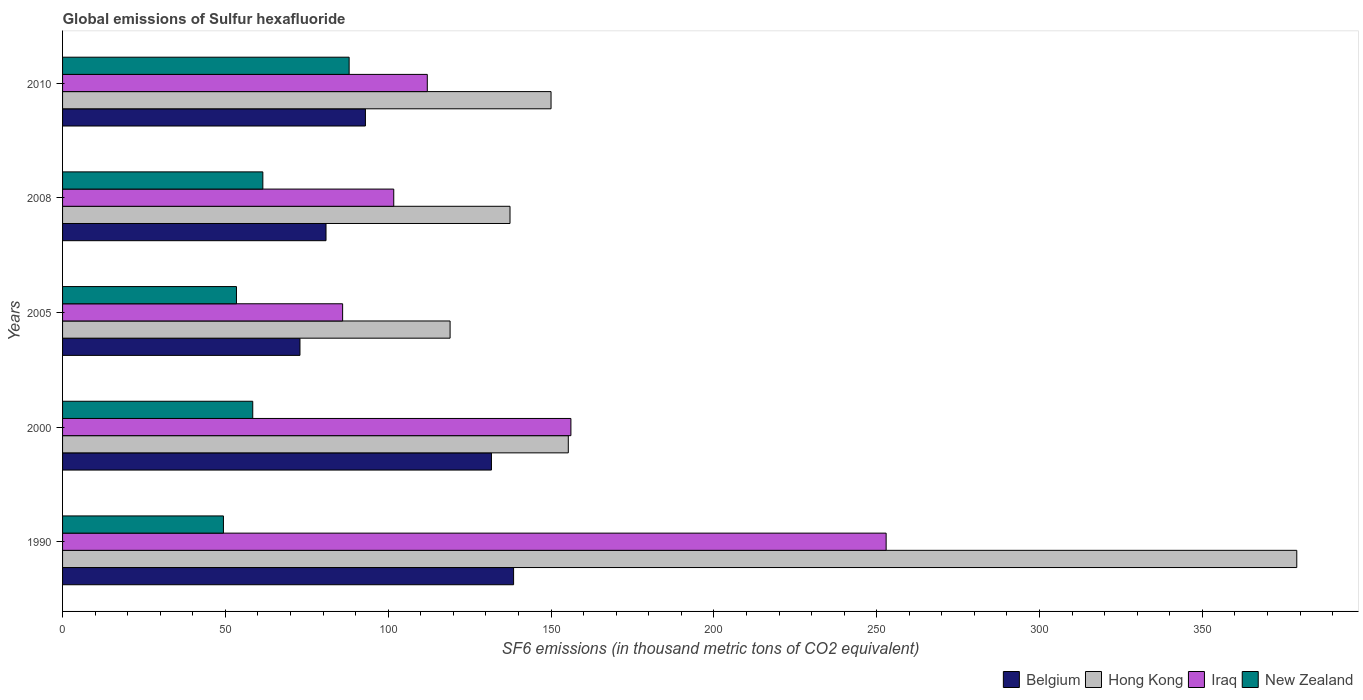How many different coloured bars are there?
Provide a succinct answer. 4. Are the number of bars per tick equal to the number of legend labels?
Your answer should be compact. Yes. In how many cases, is the number of bars for a given year not equal to the number of legend labels?
Keep it short and to the point. 0. What is the global emissions of Sulfur hexafluoride in Belgium in 2008?
Your response must be concise. 80.9. Across all years, what is the maximum global emissions of Sulfur hexafluoride in Hong Kong?
Your answer should be very brief. 379. In which year was the global emissions of Sulfur hexafluoride in Hong Kong minimum?
Your answer should be compact. 2005. What is the total global emissions of Sulfur hexafluoride in Hong Kong in the graph?
Your answer should be very brief. 940.7. What is the difference between the global emissions of Sulfur hexafluoride in Iraq in 1990 and that in 2010?
Offer a terse response. 140.9. What is the difference between the global emissions of Sulfur hexafluoride in Belgium in 2010 and the global emissions of Sulfur hexafluoride in Iraq in 2000?
Offer a terse response. -63.1. What is the average global emissions of Sulfur hexafluoride in Iraq per year?
Give a very brief answer. 141.74. In the year 1990, what is the difference between the global emissions of Sulfur hexafluoride in New Zealand and global emissions of Sulfur hexafluoride in Belgium?
Provide a succinct answer. -89.1. What is the ratio of the global emissions of Sulfur hexafluoride in New Zealand in 2008 to that in 2010?
Provide a succinct answer. 0.7. Is the global emissions of Sulfur hexafluoride in Iraq in 1990 less than that in 2000?
Your answer should be compact. No. What is the difference between the highest and the lowest global emissions of Sulfur hexafluoride in Iraq?
Your answer should be very brief. 166.9. What does the 2nd bar from the bottom in 2005 represents?
Make the answer very short. Hong Kong. Are all the bars in the graph horizontal?
Provide a succinct answer. Yes. How many years are there in the graph?
Provide a short and direct response. 5. Where does the legend appear in the graph?
Offer a terse response. Bottom right. How many legend labels are there?
Offer a terse response. 4. What is the title of the graph?
Give a very brief answer. Global emissions of Sulfur hexafluoride. What is the label or title of the X-axis?
Make the answer very short. SF6 emissions (in thousand metric tons of CO2 equivalent). What is the SF6 emissions (in thousand metric tons of CO2 equivalent) in Belgium in 1990?
Provide a short and direct response. 138.5. What is the SF6 emissions (in thousand metric tons of CO2 equivalent) of Hong Kong in 1990?
Ensure brevity in your answer.  379. What is the SF6 emissions (in thousand metric tons of CO2 equivalent) in Iraq in 1990?
Offer a terse response. 252.9. What is the SF6 emissions (in thousand metric tons of CO2 equivalent) in New Zealand in 1990?
Offer a terse response. 49.4. What is the SF6 emissions (in thousand metric tons of CO2 equivalent) in Belgium in 2000?
Provide a succinct answer. 131.7. What is the SF6 emissions (in thousand metric tons of CO2 equivalent) of Hong Kong in 2000?
Your response must be concise. 155.3. What is the SF6 emissions (in thousand metric tons of CO2 equivalent) of Iraq in 2000?
Keep it short and to the point. 156.1. What is the SF6 emissions (in thousand metric tons of CO2 equivalent) of New Zealand in 2000?
Your response must be concise. 58.4. What is the SF6 emissions (in thousand metric tons of CO2 equivalent) in Belgium in 2005?
Your response must be concise. 72.9. What is the SF6 emissions (in thousand metric tons of CO2 equivalent) of Hong Kong in 2005?
Your answer should be compact. 119. What is the SF6 emissions (in thousand metric tons of CO2 equivalent) in New Zealand in 2005?
Provide a short and direct response. 53.4. What is the SF6 emissions (in thousand metric tons of CO2 equivalent) of Belgium in 2008?
Make the answer very short. 80.9. What is the SF6 emissions (in thousand metric tons of CO2 equivalent) in Hong Kong in 2008?
Ensure brevity in your answer.  137.4. What is the SF6 emissions (in thousand metric tons of CO2 equivalent) in Iraq in 2008?
Your answer should be very brief. 101.7. What is the SF6 emissions (in thousand metric tons of CO2 equivalent) in New Zealand in 2008?
Provide a short and direct response. 61.5. What is the SF6 emissions (in thousand metric tons of CO2 equivalent) in Belgium in 2010?
Ensure brevity in your answer.  93. What is the SF6 emissions (in thousand metric tons of CO2 equivalent) of Hong Kong in 2010?
Give a very brief answer. 150. What is the SF6 emissions (in thousand metric tons of CO2 equivalent) in Iraq in 2010?
Your answer should be very brief. 112. What is the SF6 emissions (in thousand metric tons of CO2 equivalent) in New Zealand in 2010?
Ensure brevity in your answer.  88. Across all years, what is the maximum SF6 emissions (in thousand metric tons of CO2 equivalent) of Belgium?
Your answer should be compact. 138.5. Across all years, what is the maximum SF6 emissions (in thousand metric tons of CO2 equivalent) in Hong Kong?
Your response must be concise. 379. Across all years, what is the maximum SF6 emissions (in thousand metric tons of CO2 equivalent) in Iraq?
Your response must be concise. 252.9. Across all years, what is the minimum SF6 emissions (in thousand metric tons of CO2 equivalent) of Belgium?
Make the answer very short. 72.9. Across all years, what is the minimum SF6 emissions (in thousand metric tons of CO2 equivalent) of Hong Kong?
Offer a terse response. 119. Across all years, what is the minimum SF6 emissions (in thousand metric tons of CO2 equivalent) in Iraq?
Offer a very short reply. 86. Across all years, what is the minimum SF6 emissions (in thousand metric tons of CO2 equivalent) in New Zealand?
Offer a very short reply. 49.4. What is the total SF6 emissions (in thousand metric tons of CO2 equivalent) of Belgium in the graph?
Provide a short and direct response. 517. What is the total SF6 emissions (in thousand metric tons of CO2 equivalent) of Hong Kong in the graph?
Provide a short and direct response. 940.7. What is the total SF6 emissions (in thousand metric tons of CO2 equivalent) in Iraq in the graph?
Give a very brief answer. 708.7. What is the total SF6 emissions (in thousand metric tons of CO2 equivalent) of New Zealand in the graph?
Ensure brevity in your answer.  310.7. What is the difference between the SF6 emissions (in thousand metric tons of CO2 equivalent) in Belgium in 1990 and that in 2000?
Make the answer very short. 6.8. What is the difference between the SF6 emissions (in thousand metric tons of CO2 equivalent) in Hong Kong in 1990 and that in 2000?
Make the answer very short. 223.7. What is the difference between the SF6 emissions (in thousand metric tons of CO2 equivalent) of Iraq in 1990 and that in 2000?
Your answer should be very brief. 96.8. What is the difference between the SF6 emissions (in thousand metric tons of CO2 equivalent) of Belgium in 1990 and that in 2005?
Give a very brief answer. 65.6. What is the difference between the SF6 emissions (in thousand metric tons of CO2 equivalent) in Hong Kong in 1990 and that in 2005?
Provide a succinct answer. 260. What is the difference between the SF6 emissions (in thousand metric tons of CO2 equivalent) in Iraq in 1990 and that in 2005?
Offer a terse response. 166.9. What is the difference between the SF6 emissions (in thousand metric tons of CO2 equivalent) of Belgium in 1990 and that in 2008?
Give a very brief answer. 57.6. What is the difference between the SF6 emissions (in thousand metric tons of CO2 equivalent) of Hong Kong in 1990 and that in 2008?
Offer a very short reply. 241.6. What is the difference between the SF6 emissions (in thousand metric tons of CO2 equivalent) in Iraq in 1990 and that in 2008?
Give a very brief answer. 151.2. What is the difference between the SF6 emissions (in thousand metric tons of CO2 equivalent) in New Zealand in 1990 and that in 2008?
Make the answer very short. -12.1. What is the difference between the SF6 emissions (in thousand metric tons of CO2 equivalent) of Belgium in 1990 and that in 2010?
Offer a terse response. 45.5. What is the difference between the SF6 emissions (in thousand metric tons of CO2 equivalent) of Hong Kong in 1990 and that in 2010?
Give a very brief answer. 229. What is the difference between the SF6 emissions (in thousand metric tons of CO2 equivalent) in Iraq in 1990 and that in 2010?
Your answer should be very brief. 140.9. What is the difference between the SF6 emissions (in thousand metric tons of CO2 equivalent) of New Zealand in 1990 and that in 2010?
Provide a short and direct response. -38.6. What is the difference between the SF6 emissions (in thousand metric tons of CO2 equivalent) of Belgium in 2000 and that in 2005?
Provide a succinct answer. 58.8. What is the difference between the SF6 emissions (in thousand metric tons of CO2 equivalent) of Hong Kong in 2000 and that in 2005?
Your answer should be compact. 36.3. What is the difference between the SF6 emissions (in thousand metric tons of CO2 equivalent) of Iraq in 2000 and that in 2005?
Your response must be concise. 70.1. What is the difference between the SF6 emissions (in thousand metric tons of CO2 equivalent) in Belgium in 2000 and that in 2008?
Make the answer very short. 50.8. What is the difference between the SF6 emissions (in thousand metric tons of CO2 equivalent) in Iraq in 2000 and that in 2008?
Offer a very short reply. 54.4. What is the difference between the SF6 emissions (in thousand metric tons of CO2 equivalent) in New Zealand in 2000 and that in 2008?
Provide a short and direct response. -3.1. What is the difference between the SF6 emissions (in thousand metric tons of CO2 equivalent) of Belgium in 2000 and that in 2010?
Give a very brief answer. 38.7. What is the difference between the SF6 emissions (in thousand metric tons of CO2 equivalent) of Hong Kong in 2000 and that in 2010?
Ensure brevity in your answer.  5.3. What is the difference between the SF6 emissions (in thousand metric tons of CO2 equivalent) in Iraq in 2000 and that in 2010?
Make the answer very short. 44.1. What is the difference between the SF6 emissions (in thousand metric tons of CO2 equivalent) of New Zealand in 2000 and that in 2010?
Your response must be concise. -29.6. What is the difference between the SF6 emissions (in thousand metric tons of CO2 equivalent) of Belgium in 2005 and that in 2008?
Keep it short and to the point. -8. What is the difference between the SF6 emissions (in thousand metric tons of CO2 equivalent) in Hong Kong in 2005 and that in 2008?
Provide a succinct answer. -18.4. What is the difference between the SF6 emissions (in thousand metric tons of CO2 equivalent) of Iraq in 2005 and that in 2008?
Provide a succinct answer. -15.7. What is the difference between the SF6 emissions (in thousand metric tons of CO2 equivalent) in Belgium in 2005 and that in 2010?
Provide a succinct answer. -20.1. What is the difference between the SF6 emissions (in thousand metric tons of CO2 equivalent) in Hong Kong in 2005 and that in 2010?
Provide a short and direct response. -31. What is the difference between the SF6 emissions (in thousand metric tons of CO2 equivalent) in Iraq in 2005 and that in 2010?
Provide a short and direct response. -26. What is the difference between the SF6 emissions (in thousand metric tons of CO2 equivalent) of New Zealand in 2005 and that in 2010?
Your answer should be very brief. -34.6. What is the difference between the SF6 emissions (in thousand metric tons of CO2 equivalent) in Belgium in 2008 and that in 2010?
Your answer should be compact. -12.1. What is the difference between the SF6 emissions (in thousand metric tons of CO2 equivalent) of Iraq in 2008 and that in 2010?
Provide a succinct answer. -10.3. What is the difference between the SF6 emissions (in thousand metric tons of CO2 equivalent) in New Zealand in 2008 and that in 2010?
Your response must be concise. -26.5. What is the difference between the SF6 emissions (in thousand metric tons of CO2 equivalent) of Belgium in 1990 and the SF6 emissions (in thousand metric tons of CO2 equivalent) of Hong Kong in 2000?
Keep it short and to the point. -16.8. What is the difference between the SF6 emissions (in thousand metric tons of CO2 equivalent) in Belgium in 1990 and the SF6 emissions (in thousand metric tons of CO2 equivalent) in Iraq in 2000?
Provide a succinct answer. -17.6. What is the difference between the SF6 emissions (in thousand metric tons of CO2 equivalent) of Belgium in 1990 and the SF6 emissions (in thousand metric tons of CO2 equivalent) of New Zealand in 2000?
Keep it short and to the point. 80.1. What is the difference between the SF6 emissions (in thousand metric tons of CO2 equivalent) in Hong Kong in 1990 and the SF6 emissions (in thousand metric tons of CO2 equivalent) in Iraq in 2000?
Keep it short and to the point. 222.9. What is the difference between the SF6 emissions (in thousand metric tons of CO2 equivalent) in Hong Kong in 1990 and the SF6 emissions (in thousand metric tons of CO2 equivalent) in New Zealand in 2000?
Offer a terse response. 320.6. What is the difference between the SF6 emissions (in thousand metric tons of CO2 equivalent) of Iraq in 1990 and the SF6 emissions (in thousand metric tons of CO2 equivalent) of New Zealand in 2000?
Your answer should be compact. 194.5. What is the difference between the SF6 emissions (in thousand metric tons of CO2 equivalent) in Belgium in 1990 and the SF6 emissions (in thousand metric tons of CO2 equivalent) in Hong Kong in 2005?
Offer a very short reply. 19.5. What is the difference between the SF6 emissions (in thousand metric tons of CO2 equivalent) of Belgium in 1990 and the SF6 emissions (in thousand metric tons of CO2 equivalent) of Iraq in 2005?
Give a very brief answer. 52.5. What is the difference between the SF6 emissions (in thousand metric tons of CO2 equivalent) in Belgium in 1990 and the SF6 emissions (in thousand metric tons of CO2 equivalent) in New Zealand in 2005?
Keep it short and to the point. 85.1. What is the difference between the SF6 emissions (in thousand metric tons of CO2 equivalent) of Hong Kong in 1990 and the SF6 emissions (in thousand metric tons of CO2 equivalent) of Iraq in 2005?
Provide a short and direct response. 293. What is the difference between the SF6 emissions (in thousand metric tons of CO2 equivalent) of Hong Kong in 1990 and the SF6 emissions (in thousand metric tons of CO2 equivalent) of New Zealand in 2005?
Ensure brevity in your answer.  325.6. What is the difference between the SF6 emissions (in thousand metric tons of CO2 equivalent) of Iraq in 1990 and the SF6 emissions (in thousand metric tons of CO2 equivalent) of New Zealand in 2005?
Your answer should be compact. 199.5. What is the difference between the SF6 emissions (in thousand metric tons of CO2 equivalent) in Belgium in 1990 and the SF6 emissions (in thousand metric tons of CO2 equivalent) in Hong Kong in 2008?
Your response must be concise. 1.1. What is the difference between the SF6 emissions (in thousand metric tons of CO2 equivalent) in Belgium in 1990 and the SF6 emissions (in thousand metric tons of CO2 equivalent) in Iraq in 2008?
Give a very brief answer. 36.8. What is the difference between the SF6 emissions (in thousand metric tons of CO2 equivalent) of Hong Kong in 1990 and the SF6 emissions (in thousand metric tons of CO2 equivalent) of Iraq in 2008?
Provide a succinct answer. 277.3. What is the difference between the SF6 emissions (in thousand metric tons of CO2 equivalent) in Hong Kong in 1990 and the SF6 emissions (in thousand metric tons of CO2 equivalent) in New Zealand in 2008?
Your response must be concise. 317.5. What is the difference between the SF6 emissions (in thousand metric tons of CO2 equivalent) of Iraq in 1990 and the SF6 emissions (in thousand metric tons of CO2 equivalent) of New Zealand in 2008?
Offer a very short reply. 191.4. What is the difference between the SF6 emissions (in thousand metric tons of CO2 equivalent) of Belgium in 1990 and the SF6 emissions (in thousand metric tons of CO2 equivalent) of Iraq in 2010?
Your answer should be compact. 26.5. What is the difference between the SF6 emissions (in thousand metric tons of CO2 equivalent) of Belgium in 1990 and the SF6 emissions (in thousand metric tons of CO2 equivalent) of New Zealand in 2010?
Provide a short and direct response. 50.5. What is the difference between the SF6 emissions (in thousand metric tons of CO2 equivalent) of Hong Kong in 1990 and the SF6 emissions (in thousand metric tons of CO2 equivalent) of Iraq in 2010?
Your answer should be compact. 267. What is the difference between the SF6 emissions (in thousand metric tons of CO2 equivalent) of Hong Kong in 1990 and the SF6 emissions (in thousand metric tons of CO2 equivalent) of New Zealand in 2010?
Give a very brief answer. 291. What is the difference between the SF6 emissions (in thousand metric tons of CO2 equivalent) of Iraq in 1990 and the SF6 emissions (in thousand metric tons of CO2 equivalent) of New Zealand in 2010?
Offer a very short reply. 164.9. What is the difference between the SF6 emissions (in thousand metric tons of CO2 equivalent) of Belgium in 2000 and the SF6 emissions (in thousand metric tons of CO2 equivalent) of Hong Kong in 2005?
Provide a succinct answer. 12.7. What is the difference between the SF6 emissions (in thousand metric tons of CO2 equivalent) in Belgium in 2000 and the SF6 emissions (in thousand metric tons of CO2 equivalent) in Iraq in 2005?
Your answer should be compact. 45.7. What is the difference between the SF6 emissions (in thousand metric tons of CO2 equivalent) of Belgium in 2000 and the SF6 emissions (in thousand metric tons of CO2 equivalent) of New Zealand in 2005?
Your response must be concise. 78.3. What is the difference between the SF6 emissions (in thousand metric tons of CO2 equivalent) in Hong Kong in 2000 and the SF6 emissions (in thousand metric tons of CO2 equivalent) in Iraq in 2005?
Give a very brief answer. 69.3. What is the difference between the SF6 emissions (in thousand metric tons of CO2 equivalent) in Hong Kong in 2000 and the SF6 emissions (in thousand metric tons of CO2 equivalent) in New Zealand in 2005?
Your answer should be very brief. 101.9. What is the difference between the SF6 emissions (in thousand metric tons of CO2 equivalent) of Iraq in 2000 and the SF6 emissions (in thousand metric tons of CO2 equivalent) of New Zealand in 2005?
Keep it short and to the point. 102.7. What is the difference between the SF6 emissions (in thousand metric tons of CO2 equivalent) in Belgium in 2000 and the SF6 emissions (in thousand metric tons of CO2 equivalent) in New Zealand in 2008?
Your answer should be very brief. 70.2. What is the difference between the SF6 emissions (in thousand metric tons of CO2 equivalent) in Hong Kong in 2000 and the SF6 emissions (in thousand metric tons of CO2 equivalent) in Iraq in 2008?
Your answer should be compact. 53.6. What is the difference between the SF6 emissions (in thousand metric tons of CO2 equivalent) of Hong Kong in 2000 and the SF6 emissions (in thousand metric tons of CO2 equivalent) of New Zealand in 2008?
Ensure brevity in your answer.  93.8. What is the difference between the SF6 emissions (in thousand metric tons of CO2 equivalent) of Iraq in 2000 and the SF6 emissions (in thousand metric tons of CO2 equivalent) of New Zealand in 2008?
Provide a succinct answer. 94.6. What is the difference between the SF6 emissions (in thousand metric tons of CO2 equivalent) of Belgium in 2000 and the SF6 emissions (in thousand metric tons of CO2 equivalent) of Hong Kong in 2010?
Keep it short and to the point. -18.3. What is the difference between the SF6 emissions (in thousand metric tons of CO2 equivalent) of Belgium in 2000 and the SF6 emissions (in thousand metric tons of CO2 equivalent) of New Zealand in 2010?
Keep it short and to the point. 43.7. What is the difference between the SF6 emissions (in thousand metric tons of CO2 equivalent) in Hong Kong in 2000 and the SF6 emissions (in thousand metric tons of CO2 equivalent) in Iraq in 2010?
Offer a terse response. 43.3. What is the difference between the SF6 emissions (in thousand metric tons of CO2 equivalent) of Hong Kong in 2000 and the SF6 emissions (in thousand metric tons of CO2 equivalent) of New Zealand in 2010?
Keep it short and to the point. 67.3. What is the difference between the SF6 emissions (in thousand metric tons of CO2 equivalent) in Iraq in 2000 and the SF6 emissions (in thousand metric tons of CO2 equivalent) in New Zealand in 2010?
Offer a terse response. 68.1. What is the difference between the SF6 emissions (in thousand metric tons of CO2 equivalent) of Belgium in 2005 and the SF6 emissions (in thousand metric tons of CO2 equivalent) of Hong Kong in 2008?
Keep it short and to the point. -64.5. What is the difference between the SF6 emissions (in thousand metric tons of CO2 equivalent) of Belgium in 2005 and the SF6 emissions (in thousand metric tons of CO2 equivalent) of Iraq in 2008?
Keep it short and to the point. -28.8. What is the difference between the SF6 emissions (in thousand metric tons of CO2 equivalent) of Hong Kong in 2005 and the SF6 emissions (in thousand metric tons of CO2 equivalent) of New Zealand in 2008?
Your answer should be compact. 57.5. What is the difference between the SF6 emissions (in thousand metric tons of CO2 equivalent) in Belgium in 2005 and the SF6 emissions (in thousand metric tons of CO2 equivalent) in Hong Kong in 2010?
Keep it short and to the point. -77.1. What is the difference between the SF6 emissions (in thousand metric tons of CO2 equivalent) of Belgium in 2005 and the SF6 emissions (in thousand metric tons of CO2 equivalent) of Iraq in 2010?
Offer a very short reply. -39.1. What is the difference between the SF6 emissions (in thousand metric tons of CO2 equivalent) of Belgium in 2005 and the SF6 emissions (in thousand metric tons of CO2 equivalent) of New Zealand in 2010?
Ensure brevity in your answer.  -15.1. What is the difference between the SF6 emissions (in thousand metric tons of CO2 equivalent) of Hong Kong in 2005 and the SF6 emissions (in thousand metric tons of CO2 equivalent) of New Zealand in 2010?
Make the answer very short. 31. What is the difference between the SF6 emissions (in thousand metric tons of CO2 equivalent) of Iraq in 2005 and the SF6 emissions (in thousand metric tons of CO2 equivalent) of New Zealand in 2010?
Your response must be concise. -2. What is the difference between the SF6 emissions (in thousand metric tons of CO2 equivalent) in Belgium in 2008 and the SF6 emissions (in thousand metric tons of CO2 equivalent) in Hong Kong in 2010?
Your answer should be very brief. -69.1. What is the difference between the SF6 emissions (in thousand metric tons of CO2 equivalent) of Belgium in 2008 and the SF6 emissions (in thousand metric tons of CO2 equivalent) of Iraq in 2010?
Offer a terse response. -31.1. What is the difference between the SF6 emissions (in thousand metric tons of CO2 equivalent) of Belgium in 2008 and the SF6 emissions (in thousand metric tons of CO2 equivalent) of New Zealand in 2010?
Your answer should be compact. -7.1. What is the difference between the SF6 emissions (in thousand metric tons of CO2 equivalent) of Hong Kong in 2008 and the SF6 emissions (in thousand metric tons of CO2 equivalent) of Iraq in 2010?
Provide a succinct answer. 25.4. What is the difference between the SF6 emissions (in thousand metric tons of CO2 equivalent) in Hong Kong in 2008 and the SF6 emissions (in thousand metric tons of CO2 equivalent) in New Zealand in 2010?
Keep it short and to the point. 49.4. What is the average SF6 emissions (in thousand metric tons of CO2 equivalent) of Belgium per year?
Provide a short and direct response. 103.4. What is the average SF6 emissions (in thousand metric tons of CO2 equivalent) of Hong Kong per year?
Your answer should be compact. 188.14. What is the average SF6 emissions (in thousand metric tons of CO2 equivalent) of Iraq per year?
Offer a terse response. 141.74. What is the average SF6 emissions (in thousand metric tons of CO2 equivalent) in New Zealand per year?
Ensure brevity in your answer.  62.14. In the year 1990, what is the difference between the SF6 emissions (in thousand metric tons of CO2 equivalent) in Belgium and SF6 emissions (in thousand metric tons of CO2 equivalent) in Hong Kong?
Your answer should be compact. -240.5. In the year 1990, what is the difference between the SF6 emissions (in thousand metric tons of CO2 equivalent) of Belgium and SF6 emissions (in thousand metric tons of CO2 equivalent) of Iraq?
Your answer should be very brief. -114.4. In the year 1990, what is the difference between the SF6 emissions (in thousand metric tons of CO2 equivalent) of Belgium and SF6 emissions (in thousand metric tons of CO2 equivalent) of New Zealand?
Your answer should be very brief. 89.1. In the year 1990, what is the difference between the SF6 emissions (in thousand metric tons of CO2 equivalent) of Hong Kong and SF6 emissions (in thousand metric tons of CO2 equivalent) of Iraq?
Ensure brevity in your answer.  126.1. In the year 1990, what is the difference between the SF6 emissions (in thousand metric tons of CO2 equivalent) in Hong Kong and SF6 emissions (in thousand metric tons of CO2 equivalent) in New Zealand?
Provide a succinct answer. 329.6. In the year 1990, what is the difference between the SF6 emissions (in thousand metric tons of CO2 equivalent) in Iraq and SF6 emissions (in thousand metric tons of CO2 equivalent) in New Zealand?
Make the answer very short. 203.5. In the year 2000, what is the difference between the SF6 emissions (in thousand metric tons of CO2 equivalent) in Belgium and SF6 emissions (in thousand metric tons of CO2 equivalent) in Hong Kong?
Your answer should be compact. -23.6. In the year 2000, what is the difference between the SF6 emissions (in thousand metric tons of CO2 equivalent) of Belgium and SF6 emissions (in thousand metric tons of CO2 equivalent) of Iraq?
Provide a succinct answer. -24.4. In the year 2000, what is the difference between the SF6 emissions (in thousand metric tons of CO2 equivalent) of Belgium and SF6 emissions (in thousand metric tons of CO2 equivalent) of New Zealand?
Offer a terse response. 73.3. In the year 2000, what is the difference between the SF6 emissions (in thousand metric tons of CO2 equivalent) in Hong Kong and SF6 emissions (in thousand metric tons of CO2 equivalent) in Iraq?
Offer a very short reply. -0.8. In the year 2000, what is the difference between the SF6 emissions (in thousand metric tons of CO2 equivalent) in Hong Kong and SF6 emissions (in thousand metric tons of CO2 equivalent) in New Zealand?
Give a very brief answer. 96.9. In the year 2000, what is the difference between the SF6 emissions (in thousand metric tons of CO2 equivalent) in Iraq and SF6 emissions (in thousand metric tons of CO2 equivalent) in New Zealand?
Your response must be concise. 97.7. In the year 2005, what is the difference between the SF6 emissions (in thousand metric tons of CO2 equivalent) in Belgium and SF6 emissions (in thousand metric tons of CO2 equivalent) in Hong Kong?
Make the answer very short. -46.1. In the year 2005, what is the difference between the SF6 emissions (in thousand metric tons of CO2 equivalent) of Belgium and SF6 emissions (in thousand metric tons of CO2 equivalent) of Iraq?
Your answer should be compact. -13.1. In the year 2005, what is the difference between the SF6 emissions (in thousand metric tons of CO2 equivalent) in Belgium and SF6 emissions (in thousand metric tons of CO2 equivalent) in New Zealand?
Make the answer very short. 19.5. In the year 2005, what is the difference between the SF6 emissions (in thousand metric tons of CO2 equivalent) in Hong Kong and SF6 emissions (in thousand metric tons of CO2 equivalent) in Iraq?
Offer a terse response. 33. In the year 2005, what is the difference between the SF6 emissions (in thousand metric tons of CO2 equivalent) of Hong Kong and SF6 emissions (in thousand metric tons of CO2 equivalent) of New Zealand?
Make the answer very short. 65.6. In the year 2005, what is the difference between the SF6 emissions (in thousand metric tons of CO2 equivalent) in Iraq and SF6 emissions (in thousand metric tons of CO2 equivalent) in New Zealand?
Keep it short and to the point. 32.6. In the year 2008, what is the difference between the SF6 emissions (in thousand metric tons of CO2 equivalent) in Belgium and SF6 emissions (in thousand metric tons of CO2 equivalent) in Hong Kong?
Offer a very short reply. -56.5. In the year 2008, what is the difference between the SF6 emissions (in thousand metric tons of CO2 equivalent) of Belgium and SF6 emissions (in thousand metric tons of CO2 equivalent) of Iraq?
Your answer should be compact. -20.8. In the year 2008, what is the difference between the SF6 emissions (in thousand metric tons of CO2 equivalent) of Belgium and SF6 emissions (in thousand metric tons of CO2 equivalent) of New Zealand?
Ensure brevity in your answer.  19.4. In the year 2008, what is the difference between the SF6 emissions (in thousand metric tons of CO2 equivalent) of Hong Kong and SF6 emissions (in thousand metric tons of CO2 equivalent) of Iraq?
Provide a succinct answer. 35.7. In the year 2008, what is the difference between the SF6 emissions (in thousand metric tons of CO2 equivalent) in Hong Kong and SF6 emissions (in thousand metric tons of CO2 equivalent) in New Zealand?
Your answer should be very brief. 75.9. In the year 2008, what is the difference between the SF6 emissions (in thousand metric tons of CO2 equivalent) of Iraq and SF6 emissions (in thousand metric tons of CO2 equivalent) of New Zealand?
Ensure brevity in your answer.  40.2. In the year 2010, what is the difference between the SF6 emissions (in thousand metric tons of CO2 equivalent) in Belgium and SF6 emissions (in thousand metric tons of CO2 equivalent) in Hong Kong?
Offer a very short reply. -57. In the year 2010, what is the difference between the SF6 emissions (in thousand metric tons of CO2 equivalent) of Belgium and SF6 emissions (in thousand metric tons of CO2 equivalent) of New Zealand?
Offer a terse response. 5. In the year 2010, what is the difference between the SF6 emissions (in thousand metric tons of CO2 equivalent) in Iraq and SF6 emissions (in thousand metric tons of CO2 equivalent) in New Zealand?
Offer a terse response. 24. What is the ratio of the SF6 emissions (in thousand metric tons of CO2 equivalent) of Belgium in 1990 to that in 2000?
Your answer should be compact. 1.05. What is the ratio of the SF6 emissions (in thousand metric tons of CO2 equivalent) in Hong Kong in 1990 to that in 2000?
Offer a terse response. 2.44. What is the ratio of the SF6 emissions (in thousand metric tons of CO2 equivalent) of Iraq in 1990 to that in 2000?
Your answer should be very brief. 1.62. What is the ratio of the SF6 emissions (in thousand metric tons of CO2 equivalent) of New Zealand in 1990 to that in 2000?
Ensure brevity in your answer.  0.85. What is the ratio of the SF6 emissions (in thousand metric tons of CO2 equivalent) in Belgium in 1990 to that in 2005?
Offer a terse response. 1.9. What is the ratio of the SF6 emissions (in thousand metric tons of CO2 equivalent) of Hong Kong in 1990 to that in 2005?
Give a very brief answer. 3.18. What is the ratio of the SF6 emissions (in thousand metric tons of CO2 equivalent) in Iraq in 1990 to that in 2005?
Make the answer very short. 2.94. What is the ratio of the SF6 emissions (in thousand metric tons of CO2 equivalent) of New Zealand in 1990 to that in 2005?
Offer a very short reply. 0.93. What is the ratio of the SF6 emissions (in thousand metric tons of CO2 equivalent) of Belgium in 1990 to that in 2008?
Give a very brief answer. 1.71. What is the ratio of the SF6 emissions (in thousand metric tons of CO2 equivalent) of Hong Kong in 1990 to that in 2008?
Your answer should be compact. 2.76. What is the ratio of the SF6 emissions (in thousand metric tons of CO2 equivalent) in Iraq in 1990 to that in 2008?
Give a very brief answer. 2.49. What is the ratio of the SF6 emissions (in thousand metric tons of CO2 equivalent) in New Zealand in 1990 to that in 2008?
Make the answer very short. 0.8. What is the ratio of the SF6 emissions (in thousand metric tons of CO2 equivalent) of Belgium in 1990 to that in 2010?
Your response must be concise. 1.49. What is the ratio of the SF6 emissions (in thousand metric tons of CO2 equivalent) of Hong Kong in 1990 to that in 2010?
Your answer should be compact. 2.53. What is the ratio of the SF6 emissions (in thousand metric tons of CO2 equivalent) in Iraq in 1990 to that in 2010?
Provide a succinct answer. 2.26. What is the ratio of the SF6 emissions (in thousand metric tons of CO2 equivalent) of New Zealand in 1990 to that in 2010?
Offer a very short reply. 0.56. What is the ratio of the SF6 emissions (in thousand metric tons of CO2 equivalent) of Belgium in 2000 to that in 2005?
Your answer should be very brief. 1.81. What is the ratio of the SF6 emissions (in thousand metric tons of CO2 equivalent) in Hong Kong in 2000 to that in 2005?
Provide a short and direct response. 1.3. What is the ratio of the SF6 emissions (in thousand metric tons of CO2 equivalent) in Iraq in 2000 to that in 2005?
Keep it short and to the point. 1.82. What is the ratio of the SF6 emissions (in thousand metric tons of CO2 equivalent) in New Zealand in 2000 to that in 2005?
Make the answer very short. 1.09. What is the ratio of the SF6 emissions (in thousand metric tons of CO2 equivalent) in Belgium in 2000 to that in 2008?
Provide a short and direct response. 1.63. What is the ratio of the SF6 emissions (in thousand metric tons of CO2 equivalent) of Hong Kong in 2000 to that in 2008?
Keep it short and to the point. 1.13. What is the ratio of the SF6 emissions (in thousand metric tons of CO2 equivalent) in Iraq in 2000 to that in 2008?
Ensure brevity in your answer.  1.53. What is the ratio of the SF6 emissions (in thousand metric tons of CO2 equivalent) of New Zealand in 2000 to that in 2008?
Give a very brief answer. 0.95. What is the ratio of the SF6 emissions (in thousand metric tons of CO2 equivalent) of Belgium in 2000 to that in 2010?
Your answer should be very brief. 1.42. What is the ratio of the SF6 emissions (in thousand metric tons of CO2 equivalent) in Hong Kong in 2000 to that in 2010?
Give a very brief answer. 1.04. What is the ratio of the SF6 emissions (in thousand metric tons of CO2 equivalent) in Iraq in 2000 to that in 2010?
Offer a terse response. 1.39. What is the ratio of the SF6 emissions (in thousand metric tons of CO2 equivalent) of New Zealand in 2000 to that in 2010?
Provide a succinct answer. 0.66. What is the ratio of the SF6 emissions (in thousand metric tons of CO2 equivalent) in Belgium in 2005 to that in 2008?
Keep it short and to the point. 0.9. What is the ratio of the SF6 emissions (in thousand metric tons of CO2 equivalent) in Hong Kong in 2005 to that in 2008?
Ensure brevity in your answer.  0.87. What is the ratio of the SF6 emissions (in thousand metric tons of CO2 equivalent) of Iraq in 2005 to that in 2008?
Provide a succinct answer. 0.85. What is the ratio of the SF6 emissions (in thousand metric tons of CO2 equivalent) in New Zealand in 2005 to that in 2008?
Provide a succinct answer. 0.87. What is the ratio of the SF6 emissions (in thousand metric tons of CO2 equivalent) in Belgium in 2005 to that in 2010?
Your answer should be compact. 0.78. What is the ratio of the SF6 emissions (in thousand metric tons of CO2 equivalent) in Hong Kong in 2005 to that in 2010?
Make the answer very short. 0.79. What is the ratio of the SF6 emissions (in thousand metric tons of CO2 equivalent) of Iraq in 2005 to that in 2010?
Ensure brevity in your answer.  0.77. What is the ratio of the SF6 emissions (in thousand metric tons of CO2 equivalent) of New Zealand in 2005 to that in 2010?
Keep it short and to the point. 0.61. What is the ratio of the SF6 emissions (in thousand metric tons of CO2 equivalent) in Belgium in 2008 to that in 2010?
Provide a short and direct response. 0.87. What is the ratio of the SF6 emissions (in thousand metric tons of CO2 equivalent) of Hong Kong in 2008 to that in 2010?
Keep it short and to the point. 0.92. What is the ratio of the SF6 emissions (in thousand metric tons of CO2 equivalent) of Iraq in 2008 to that in 2010?
Provide a succinct answer. 0.91. What is the ratio of the SF6 emissions (in thousand metric tons of CO2 equivalent) of New Zealand in 2008 to that in 2010?
Provide a succinct answer. 0.7. What is the difference between the highest and the second highest SF6 emissions (in thousand metric tons of CO2 equivalent) of Hong Kong?
Offer a very short reply. 223.7. What is the difference between the highest and the second highest SF6 emissions (in thousand metric tons of CO2 equivalent) of Iraq?
Your answer should be compact. 96.8. What is the difference between the highest and the lowest SF6 emissions (in thousand metric tons of CO2 equivalent) of Belgium?
Ensure brevity in your answer.  65.6. What is the difference between the highest and the lowest SF6 emissions (in thousand metric tons of CO2 equivalent) of Hong Kong?
Ensure brevity in your answer.  260. What is the difference between the highest and the lowest SF6 emissions (in thousand metric tons of CO2 equivalent) in Iraq?
Ensure brevity in your answer.  166.9. What is the difference between the highest and the lowest SF6 emissions (in thousand metric tons of CO2 equivalent) in New Zealand?
Offer a very short reply. 38.6. 